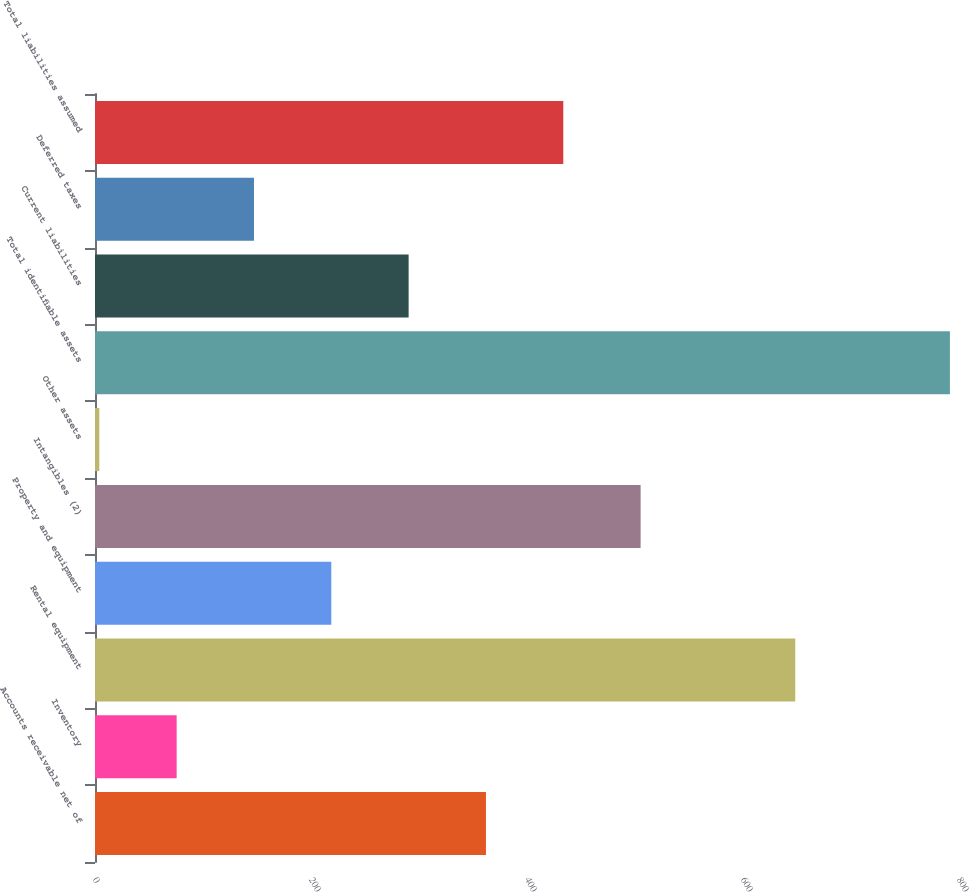Convert chart to OTSL. <chart><loc_0><loc_0><loc_500><loc_500><bar_chart><fcel>Accounts receivable net of<fcel>Inventory<fcel>Rental equipment<fcel>Property and equipment<fcel>Intangibles (2)<fcel>Other assets<fcel>Total identifiable assets<fcel>Current liabilities<fcel>Deferred taxes<fcel>Total liabilities assumed<nl><fcel>362<fcel>75.6<fcel>648.4<fcel>218.8<fcel>505.2<fcel>4<fcel>791.6<fcel>290.4<fcel>147.2<fcel>433.6<nl></chart> 